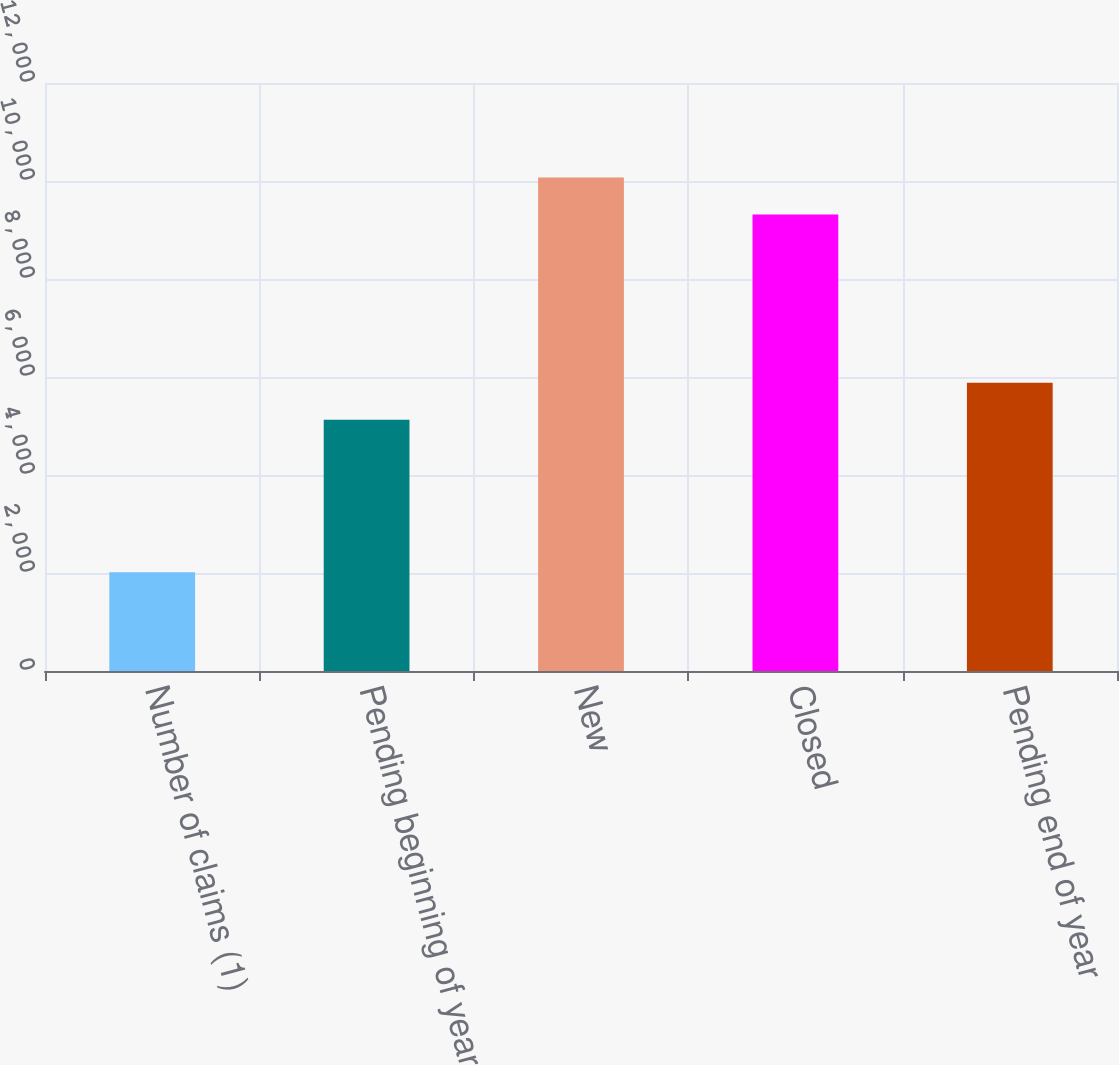Convert chart. <chart><loc_0><loc_0><loc_500><loc_500><bar_chart><fcel>Number of claims (1)<fcel>Pending beginning of year<fcel>New<fcel>Closed<fcel>Pending end of year<nl><fcel>2016<fcel>5127<fcel>10072.1<fcel>9316<fcel>5883.1<nl></chart> 